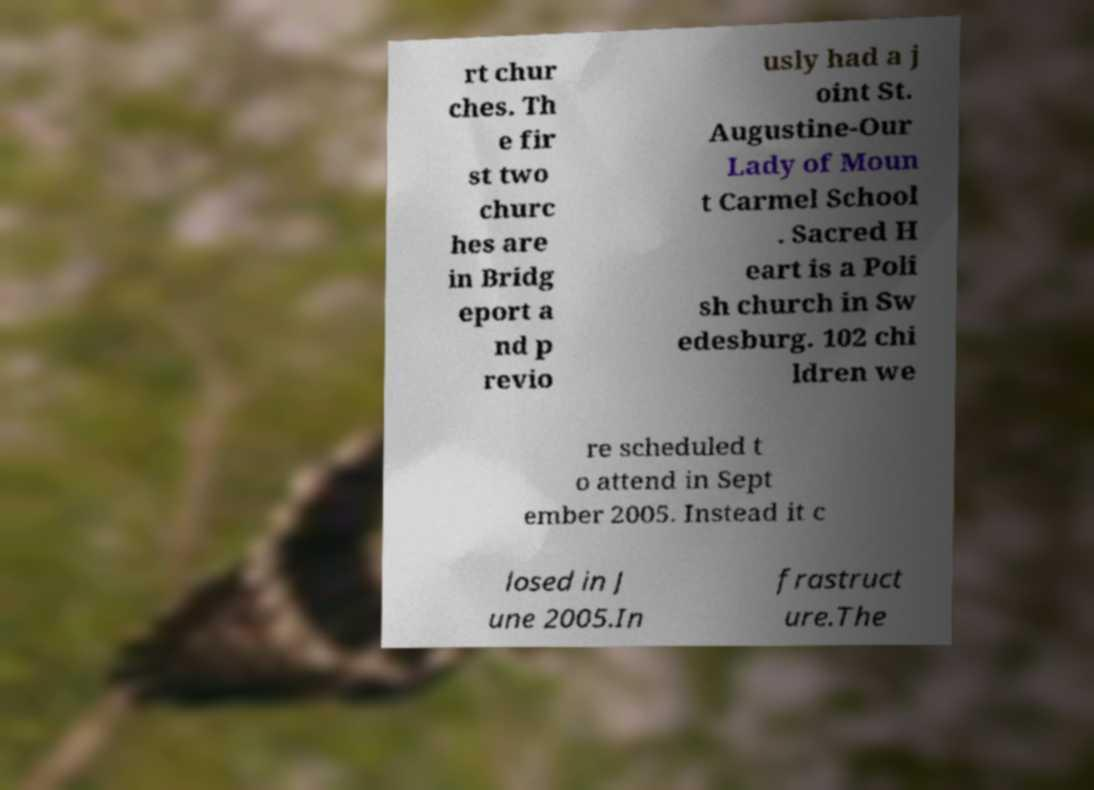There's text embedded in this image that I need extracted. Can you transcribe it verbatim? rt chur ches. Th e fir st two churc hes are in Bridg eport a nd p revio usly had a j oint St. Augustine-Our Lady of Moun t Carmel School . Sacred H eart is a Poli sh church in Sw edesburg. 102 chi ldren we re scheduled t o attend in Sept ember 2005. Instead it c losed in J une 2005.In frastruct ure.The 